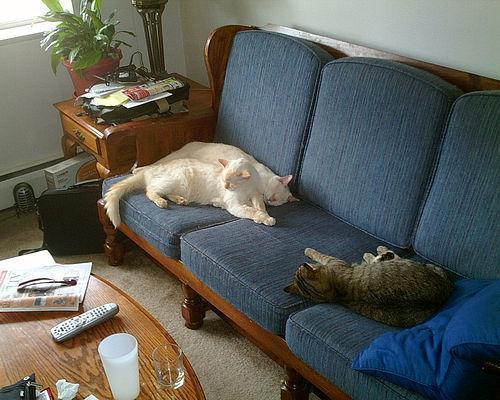What is the silver object on the table in front of the couch used to control?
Indicate the correct response by choosing from the four available options to answer the question.
Options: Lights, garage door, fan, tv. Tv. 